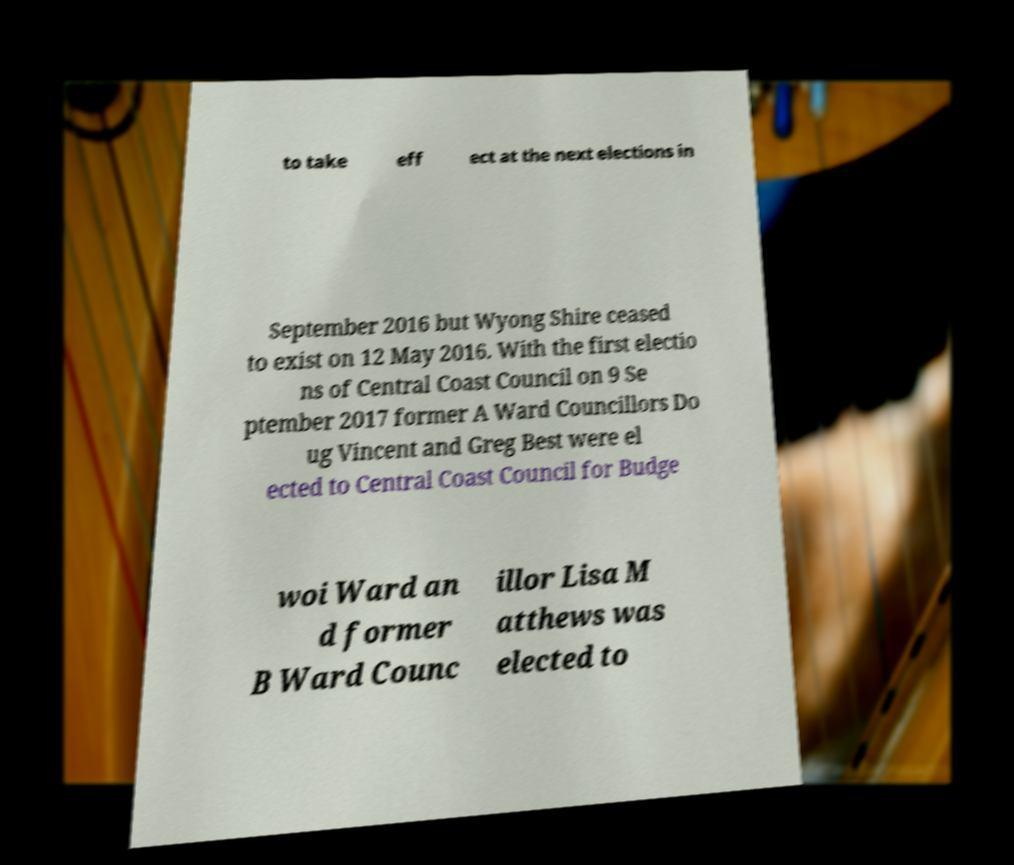For documentation purposes, I need the text within this image transcribed. Could you provide that? to take eff ect at the next elections in September 2016 but Wyong Shire ceased to exist on 12 May 2016. With the first electio ns of Central Coast Council on 9 Se ptember 2017 former A Ward Councillors Do ug Vincent and Greg Best were el ected to Central Coast Council for Budge woi Ward an d former B Ward Counc illor Lisa M atthews was elected to 